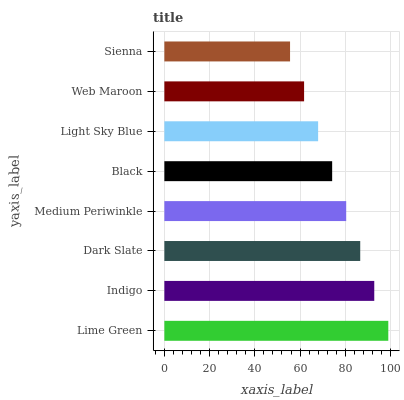Is Sienna the minimum?
Answer yes or no. Yes. Is Lime Green the maximum?
Answer yes or no. Yes. Is Indigo the minimum?
Answer yes or no. No. Is Indigo the maximum?
Answer yes or no. No. Is Lime Green greater than Indigo?
Answer yes or no. Yes. Is Indigo less than Lime Green?
Answer yes or no. Yes. Is Indigo greater than Lime Green?
Answer yes or no. No. Is Lime Green less than Indigo?
Answer yes or no. No. Is Medium Periwinkle the high median?
Answer yes or no. Yes. Is Black the low median?
Answer yes or no. Yes. Is Lime Green the high median?
Answer yes or no. No. Is Indigo the low median?
Answer yes or no. No. 